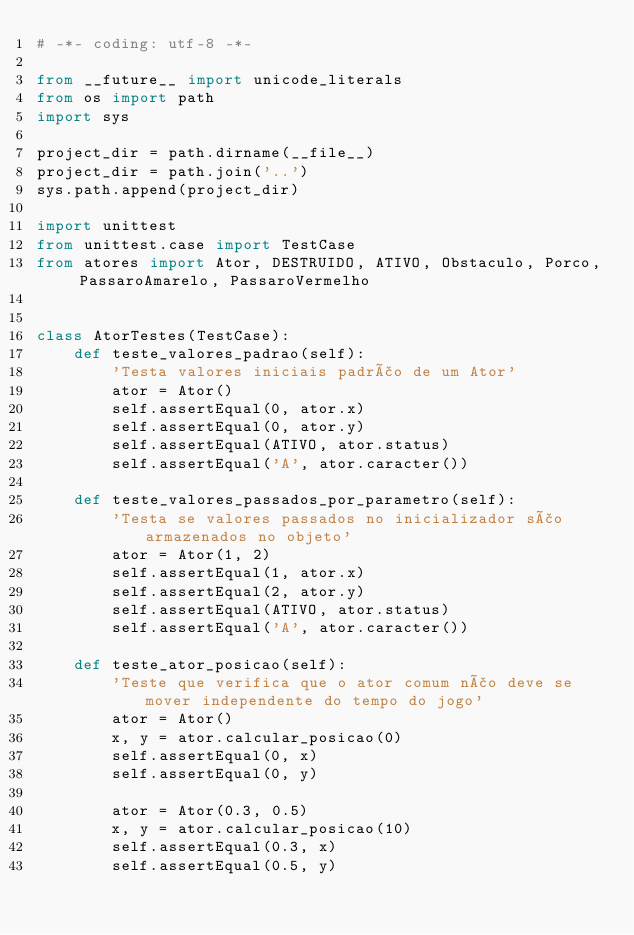Convert code to text. <code><loc_0><loc_0><loc_500><loc_500><_Python_># -*- coding: utf-8 -*-

from __future__ import unicode_literals
from os import path
import sys

project_dir = path.dirname(__file__)
project_dir = path.join('..')
sys.path.append(project_dir)

import unittest
from unittest.case import TestCase
from atores import Ator, DESTRUIDO, ATIVO, Obstaculo, Porco, PassaroAmarelo, PassaroVermelho


class AtorTestes(TestCase):
    def teste_valores_padrao(self):
        'Testa valores iniciais padrão de um Ator'
        ator = Ator()
        self.assertEqual(0, ator.x)
        self.assertEqual(0, ator.y)
        self.assertEqual(ATIVO, ator.status)
        self.assertEqual('A', ator.caracter())

    def teste_valores_passados_por_parametro(self):
        'Testa se valores passados no inicializador são armazenados no objeto'
        ator = Ator(1, 2)
        self.assertEqual(1, ator.x)
        self.assertEqual(2, ator.y)
        self.assertEqual(ATIVO, ator.status)
        self.assertEqual('A', ator.caracter())

    def teste_ator_posicao(self):
        'Teste que verifica que o ator comum não deve se mover independente do tempo do jogo'
        ator = Ator()
        x, y = ator.calcular_posicao(0)
        self.assertEqual(0, x)
        self.assertEqual(0, y)

        ator = Ator(0.3, 0.5)
        x, y = ator.calcular_posicao(10)
        self.assertEqual(0.3, x)
        self.assertEqual(0.5, y)

</code> 